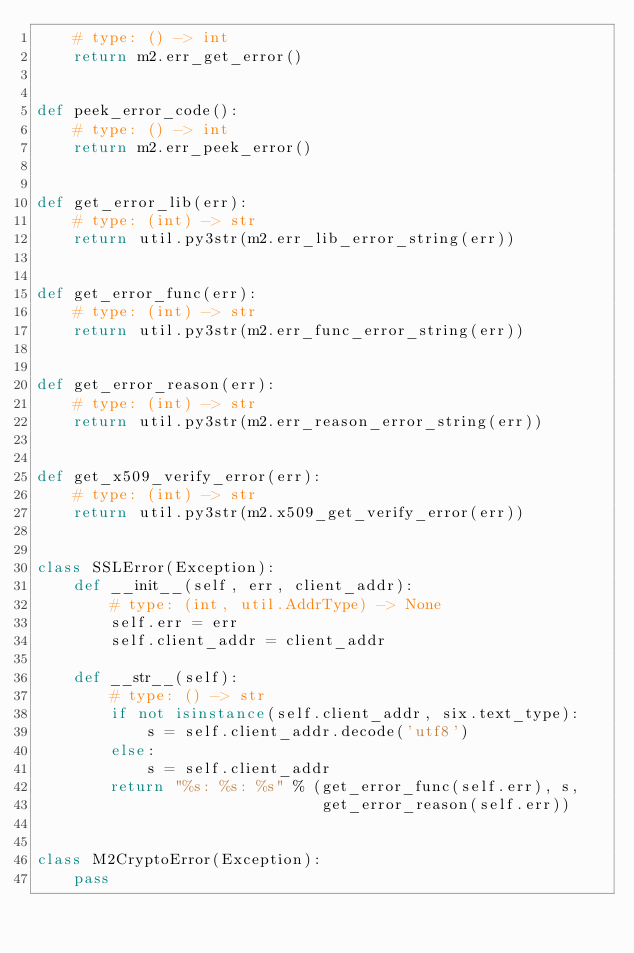<code> <loc_0><loc_0><loc_500><loc_500><_Python_>    # type: () -> int
    return m2.err_get_error()


def peek_error_code():
    # type: () -> int
    return m2.err_peek_error()


def get_error_lib(err):
    # type: (int) -> str
    return util.py3str(m2.err_lib_error_string(err))


def get_error_func(err):
    # type: (int) -> str
    return util.py3str(m2.err_func_error_string(err))


def get_error_reason(err):
    # type: (int) -> str
    return util.py3str(m2.err_reason_error_string(err))


def get_x509_verify_error(err):
    # type: (int) -> str
    return util.py3str(m2.x509_get_verify_error(err))


class SSLError(Exception):
    def __init__(self, err, client_addr):
        # type: (int, util.AddrType) -> None
        self.err = err
        self.client_addr = client_addr

    def __str__(self):
        # type: () -> str
        if not isinstance(self.client_addr, six.text_type):
            s = self.client_addr.decode('utf8')
        else:
            s = self.client_addr
        return "%s: %s: %s" % (get_error_func(self.err), s,
                               get_error_reason(self.err))


class M2CryptoError(Exception):
    pass
</code> 